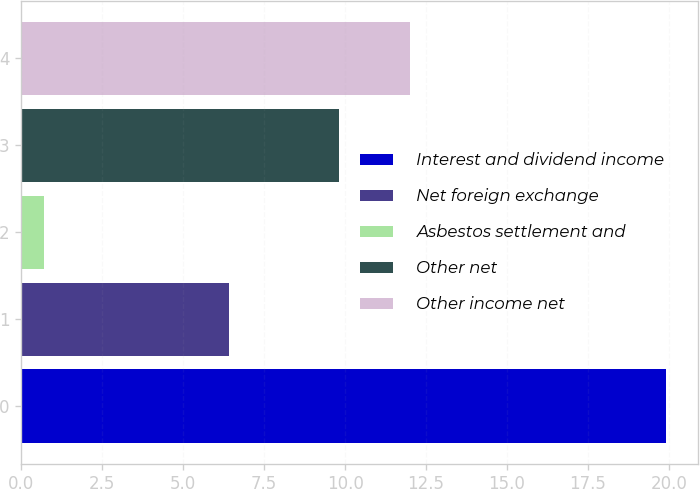Convert chart. <chart><loc_0><loc_0><loc_500><loc_500><bar_chart><fcel>Interest and dividend income<fcel>Net foreign exchange<fcel>Asbestos settlement and<fcel>Other net<fcel>Other income net<nl><fcel>19.9<fcel>6.4<fcel>0.7<fcel>9.8<fcel>12<nl></chart> 